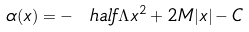<formula> <loc_0><loc_0><loc_500><loc_500>\alpha ( x ) = - \ h a l f \Lambda x ^ { 2 } + 2 M | x | - C</formula> 